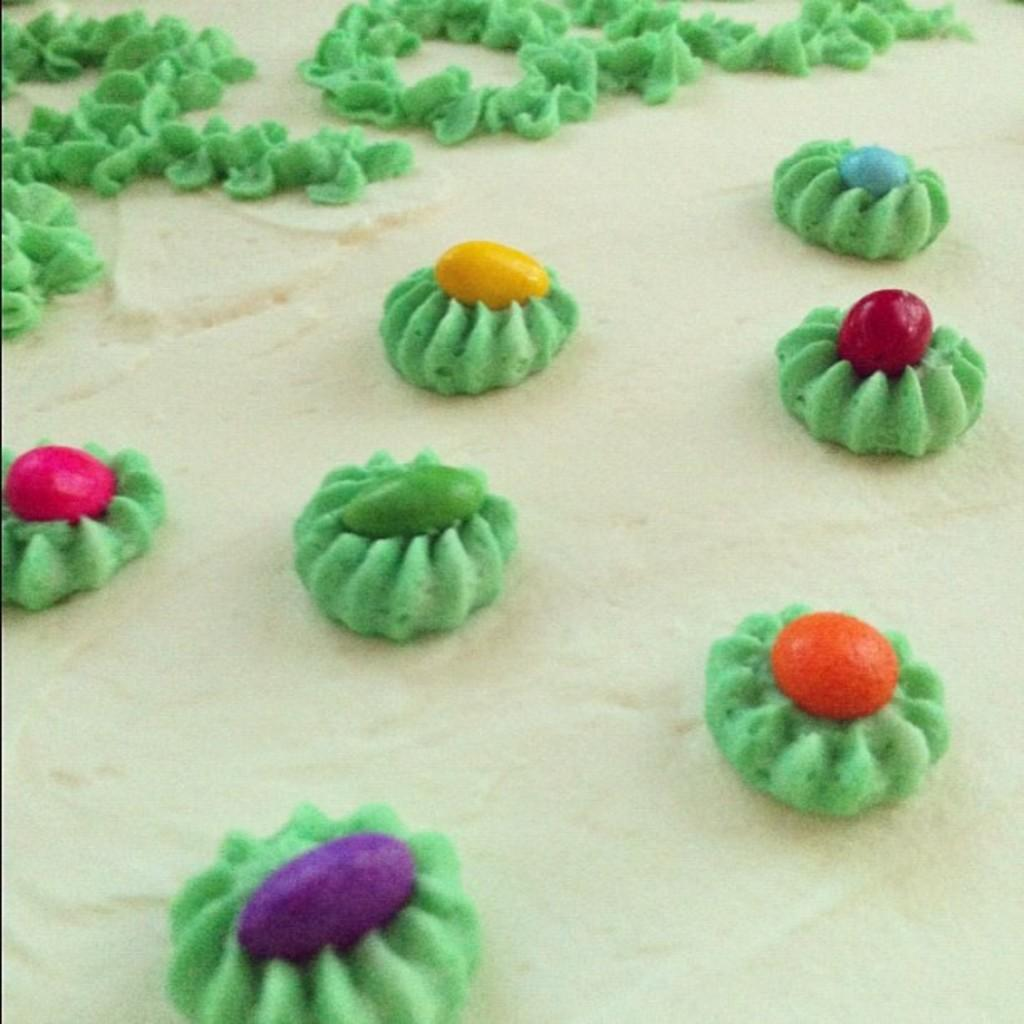What is the color of the base in the image? The base of the image is cream-colored. What types of flowers are present in the image? There are flowers with cream and green colors in the image. What fruit can be seen in the image? There are colorful cherries in the image. What is the color of the text at the top of the image? The text at the top of the image is cream-colored. Can you see a giraffe's nose in the image? There is no giraffe or its nose present in the image. What question is being asked in the image? There is no question present in the image; it contains flowers, cherries, and text. 